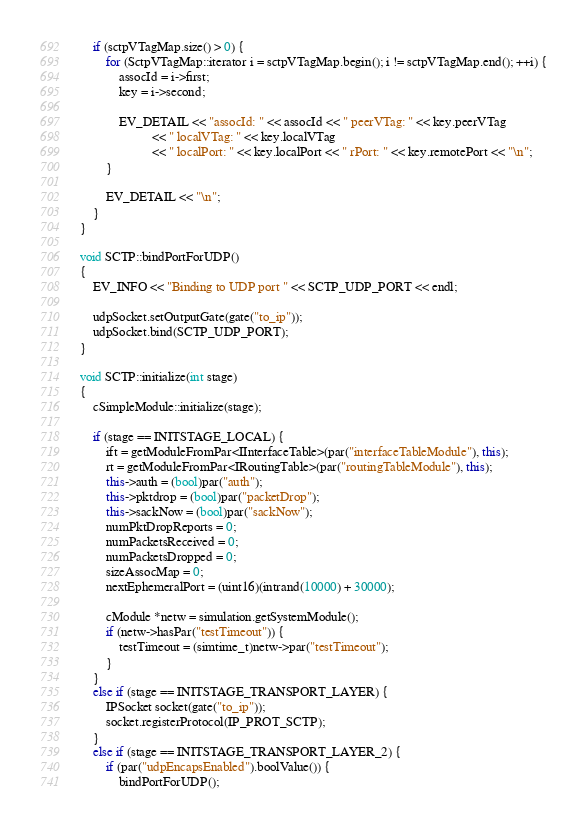<code> <loc_0><loc_0><loc_500><loc_500><_C++_>    if (sctpVTagMap.size() > 0) {
        for (SctpVTagMap::iterator i = sctpVTagMap.begin(); i != sctpVTagMap.end(); ++i) {
            assocId = i->first;
            key = i->second;

            EV_DETAIL << "assocId: " << assocId << " peerVTag: " << key.peerVTag
                      << " localVTag: " << key.localVTag
                      << " localPort: " << key.localPort << " rPort: " << key.remotePort << "\n";
        }

        EV_DETAIL << "\n";
    }
}

void SCTP::bindPortForUDP()
{
    EV_INFO << "Binding to UDP port " << SCTP_UDP_PORT << endl;

    udpSocket.setOutputGate(gate("to_ip"));
    udpSocket.bind(SCTP_UDP_PORT);
}

void SCTP::initialize(int stage)
{
    cSimpleModule::initialize(stage);

    if (stage == INITSTAGE_LOCAL) {
        ift = getModuleFromPar<IInterfaceTable>(par("interfaceTableModule"), this);
        rt = getModuleFromPar<IRoutingTable>(par("routingTableModule"), this);
        this->auth = (bool)par("auth");
        this->pktdrop = (bool)par("packetDrop");
        this->sackNow = (bool)par("sackNow");
        numPktDropReports = 0;
        numPacketsReceived = 0;
        numPacketsDropped = 0;
        sizeAssocMap = 0;
        nextEphemeralPort = (uint16)(intrand(10000) + 30000);

        cModule *netw = simulation.getSystemModule();
        if (netw->hasPar("testTimeout")) {
            testTimeout = (simtime_t)netw->par("testTimeout");
        }
    }
    else if (stage == INITSTAGE_TRANSPORT_LAYER) {
        IPSocket socket(gate("to_ip"));
        socket.registerProtocol(IP_PROT_SCTP);
    }
    else if (stage == INITSTAGE_TRANSPORT_LAYER_2) {
        if (par("udpEncapsEnabled").boolValue()) {
            bindPortForUDP();</code> 